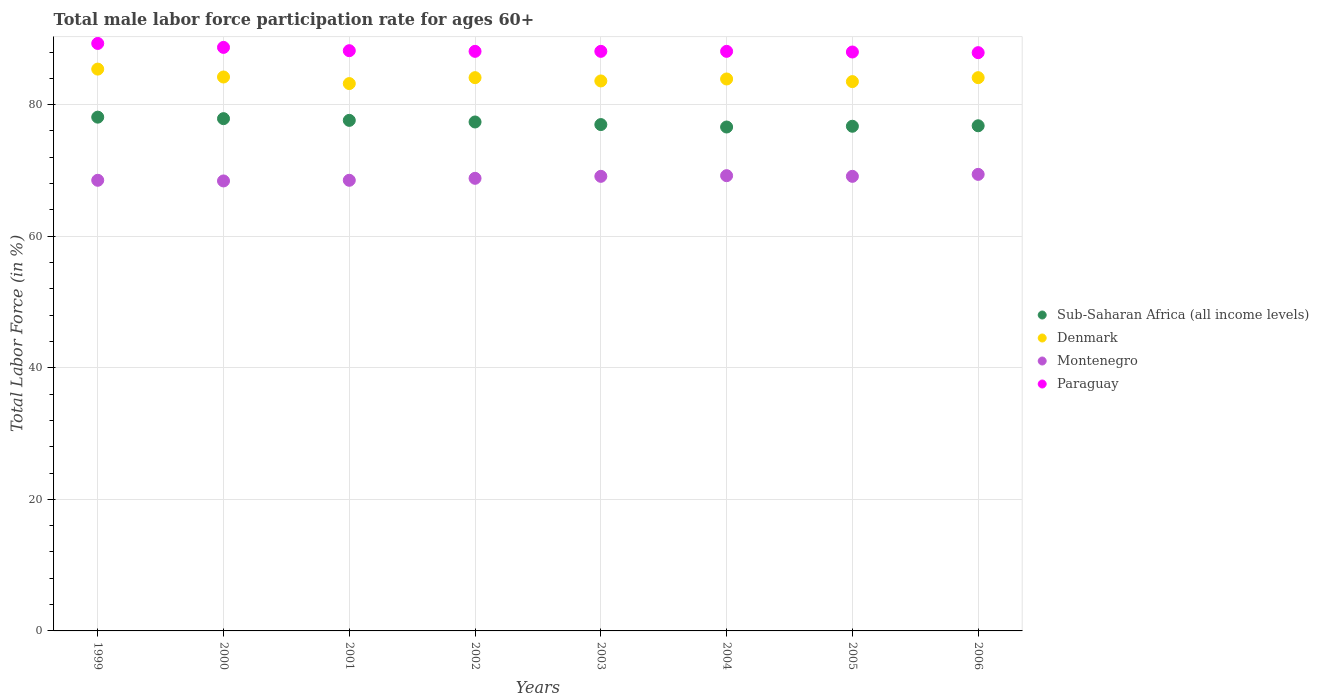What is the male labor force participation rate in Montenegro in 2002?
Your answer should be very brief. 68.8. Across all years, what is the maximum male labor force participation rate in Denmark?
Offer a very short reply. 85.4. Across all years, what is the minimum male labor force participation rate in Denmark?
Offer a very short reply. 83.2. In which year was the male labor force participation rate in Montenegro maximum?
Your answer should be very brief. 2006. What is the total male labor force participation rate in Sub-Saharan Africa (all income levels) in the graph?
Make the answer very short. 618. What is the difference between the male labor force participation rate in Denmark in 2000 and that in 2002?
Provide a succinct answer. 0.1. What is the difference between the male labor force participation rate in Paraguay in 2006 and the male labor force participation rate in Denmark in 2000?
Give a very brief answer. 3.7. What is the average male labor force participation rate in Denmark per year?
Your response must be concise. 84. In the year 1999, what is the difference between the male labor force participation rate in Montenegro and male labor force participation rate in Denmark?
Offer a very short reply. -16.9. What is the ratio of the male labor force participation rate in Sub-Saharan Africa (all income levels) in 2001 to that in 2004?
Your response must be concise. 1.01. Is the male labor force participation rate in Denmark in 1999 less than that in 2001?
Provide a succinct answer. No. What is the difference between the highest and the second highest male labor force participation rate in Sub-Saharan Africa (all income levels)?
Keep it short and to the point. 0.23. What is the difference between the highest and the lowest male labor force participation rate in Denmark?
Provide a succinct answer. 2.2. Is the male labor force participation rate in Denmark strictly greater than the male labor force participation rate in Sub-Saharan Africa (all income levels) over the years?
Offer a terse response. Yes. Is the male labor force participation rate in Paraguay strictly less than the male labor force participation rate in Denmark over the years?
Your answer should be very brief. No. How many dotlines are there?
Make the answer very short. 4. How many years are there in the graph?
Ensure brevity in your answer.  8. What is the difference between two consecutive major ticks on the Y-axis?
Provide a short and direct response. 20. Are the values on the major ticks of Y-axis written in scientific E-notation?
Your answer should be very brief. No. Does the graph contain any zero values?
Ensure brevity in your answer.  No. How many legend labels are there?
Your response must be concise. 4. What is the title of the graph?
Ensure brevity in your answer.  Total male labor force participation rate for ages 60+. Does "Heavily indebted poor countries" appear as one of the legend labels in the graph?
Keep it short and to the point. No. What is the label or title of the Y-axis?
Offer a very short reply. Total Labor Force (in %). What is the Total Labor Force (in %) of Sub-Saharan Africa (all income levels) in 1999?
Provide a succinct answer. 78.1. What is the Total Labor Force (in %) of Denmark in 1999?
Offer a terse response. 85.4. What is the Total Labor Force (in %) in Montenegro in 1999?
Make the answer very short. 68.5. What is the Total Labor Force (in %) of Paraguay in 1999?
Ensure brevity in your answer.  89.3. What is the Total Labor Force (in %) of Sub-Saharan Africa (all income levels) in 2000?
Give a very brief answer. 77.87. What is the Total Labor Force (in %) of Denmark in 2000?
Your answer should be compact. 84.2. What is the Total Labor Force (in %) of Montenegro in 2000?
Provide a short and direct response. 68.4. What is the Total Labor Force (in %) in Paraguay in 2000?
Provide a succinct answer. 88.7. What is the Total Labor Force (in %) of Sub-Saharan Africa (all income levels) in 2001?
Provide a succinct answer. 77.61. What is the Total Labor Force (in %) in Denmark in 2001?
Your response must be concise. 83.2. What is the Total Labor Force (in %) of Montenegro in 2001?
Provide a succinct answer. 68.5. What is the Total Labor Force (in %) of Paraguay in 2001?
Make the answer very short. 88.2. What is the Total Labor Force (in %) of Sub-Saharan Africa (all income levels) in 2002?
Offer a terse response. 77.36. What is the Total Labor Force (in %) of Denmark in 2002?
Your answer should be very brief. 84.1. What is the Total Labor Force (in %) of Montenegro in 2002?
Your answer should be very brief. 68.8. What is the Total Labor Force (in %) of Paraguay in 2002?
Your answer should be compact. 88.1. What is the Total Labor Force (in %) in Sub-Saharan Africa (all income levels) in 2003?
Your response must be concise. 76.97. What is the Total Labor Force (in %) of Denmark in 2003?
Make the answer very short. 83.6. What is the Total Labor Force (in %) of Montenegro in 2003?
Ensure brevity in your answer.  69.1. What is the Total Labor Force (in %) of Paraguay in 2003?
Your response must be concise. 88.1. What is the Total Labor Force (in %) in Sub-Saharan Africa (all income levels) in 2004?
Offer a terse response. 76.6. What is the Total Labor Force (in %) of Denmark in 2004?
Give a very brief answer. 83.9. What is the Total Labor Force (in %) of Montenegro in 2004?
Ensure brevity in your answer.  69.2. What is the Total Labor Force (in %) in Paraguay in 2004?
Provide a succinct answer. 88.1. What is the Total Labor Force (in %) in Sub-Saharan Africa (all income levels) in 2005?
Make the answer very short. 76.71. What is the Total Labor Force (in %) of Denmark in 2005?
Your answer should be compact. 83.5. What is the Total Labor Force (in %) of Montenegro in 2005?
Offer a very short reply. 69.1. What is the Total Labor Force (in %) of Paraguay in 2005?
Your answer should be compact. 88. What is the Total Labor Force (in %) in Sub-Saharan Africa (all income levels) in 2006?
Make the answer very short. 76.79. What is the Total Labor Force (in %) of Denmark in 2006?
Offer a very short reply. 84.1. What is the Total Labor Force (in %) in Montenegro in 2006?
Provide a short and direct response. 69.4. What is the Total Labor Force (in %) of Paraguay in 2006?
Give a very brief answer. 87.9. Across all years, what is the maximum Total Labor Force (in %) of Sub-Saharan Africa (all income levels)?
Keep it short and to the point. 78.1. Across all years, what is the maximum Total Labor Force (in %) of Denmark?
Provide a succinct answer. 85.4. Across all years, what is the maximum Total Labor Force (in %) in Montenegro?
Your answer should be compact. 69.4. Across all years, what is the maximum Total Labor Force (in %) of Paraguay?
Provide a succinct answer. 89.3. Across all years, what is the minimum Total Labor Force (in %) of Sub-Saharan Africa (all income levels)?
Offer a terse response. 76.6. Across all years, what is the minimum Total Labor Force (in %) in Denmark?
Make the answer very short. 83.2. Across all years, what is the minimum Total Labor Force (in %) in Montenegro?
Provide a succinct answer. 68.4. Across all years, what is the minimum Total Labor Force (in %) of Paraguay?
Provide a short and direct response. 87.9. What is the total Total Labor Force (in %) of Sub-Saharan Africa (all income levels) in the graph?
Your answer should be very brief. 618. What is the total Total Labor Force (in %) in Denmark in the graph?
Provide a short and direct response. 672. What is the total Total Labor Force (in %) of Montenegro in the graph?
Make the answer very short. 551. What is the total Total Labor Force (in %) of Paraguay in the graph?
Your answer should be very brief. 706.4. What is the difference between the Total Labor Force (in %) in Sub-Saharan Africa (all income levels) in 1999 and that in 2000?
Your response must be concise. 0.23. What is the difference between the Total Labor Force (in %) of Denmark in 1999 and that in 2000?
Your response must be concise. 1.2. What is the difference between the Total Labor Force (in %) in Montenegro in 1999 and that in 2000?
Ensure brevity in your answer.  0.1. What is the difference between the Total Labor Force (in %) of Sub-Saharan Africa (all income levels) in 1999 and that in 2001?
Your response must be concise. 0.49. What is the difference between the Total Labor Force (in %) of Paraguay in 1999 and that in 2001?
Your response must be concise. 1.1. What is the difference between the Total Labor Force (in %) in Sub-Saharan Africa (all income levels) in 1999 and that in 2002?
Offer a terse response. 0.73. What is the difference between the Total Labor Force (in %) of Paraguay in 1999 and that in 2002?
Keep it short and to the point. 1.2. What is the difference between the Total Labor Force (in %) in Sub-Saharan Africa (all income levels) in 1999 and that in 2003?
Ensure brevity in your answer.  1.13. What is the difference between the Total Labor Force (in %) in Denmark in 1999 and that in 2003?
Provide a succinct answer. 1.8. What is the difference between the Total Labor Force (in %) in Sub-Saharan Africa (all income levels) in 1999 and that in 2004?
Offer a terse response. 1.5. What is the difference between the Total Labor Force (in %) of Sub-Saharan Africa (all income levels) in 1999 and that in 2005?
Provide a succinct answer. 1.38. What is the difference between the Total Labor Force (in %) in Denmark in 1999 and that in 2005?
Your answer should be compact. 1.9. What is the difference between the Total Labor Force (in %) in Sub-Saharan Africa (all income levels) in 1999 and that in 2006?
Offer a terse response. 1.31. What is the difference between the Total Labor Force (in %) of Paraguay in 1999 and that in 2006?
Keep it short and to the point. 1.4. What is the difference between the Total Labor Force (in %) in Sub-Saharan Africa (all income levels) in 2000 and that in 2001?
Your answer should be very brief. 0.26. What is the difference between the Total Labor Force (in %) of Montenegro in 2000 and that in 2001?
Your response must be concise. -0.1. What is the difference between the Total Labor Force (in %) of Sub-Saharan Africa (all income levels) in 2000 and that in 2002?
Ensure brevity in your answer.  0.51. What is the difference between the Total Labor Force (in %) in Denmark in 2000 and that in 2002?
Offer a terse response. 0.1. What is the difference between the Total Labor Force (in %) of Montenegro in 2000 and that in 2002?
Provide a short and direct response. -0.4. What is the difference between the Total Labor Force (in %) in Paraguay in 2000 and that in 2002?
Your answer should be very brief. 0.6. What is the difference between the Total Labor Force (in %) of Sub-Saharan Africa (all income levels) in 2000 and that in 2003?
Give a very brief answer. 0.9. What is the difference between the Total Labor Force (in %) in Denmark in 2000 and that in 2003?
Give a very brief answer. 0.6. What is the difference between the Total Labor Force (in %) of Montenegro in 2000 and that in 2003?
Offer a very short reply. -0.7. What is the difference between the Total Labor Force (in %) in Sub-Saharan Africa (all income levels) in 2000 and that in 2004?
Provide a short and direct response. 1.27. What is the difference between the Total Labor Force (in %) in Sub-Saharan Africa (all income levels) in 2000 and that in 2005?
Offer a terse response. 1.16. What is the difference between the Total Labor Force (in %) of Denmark in 2000 and that in 2005?
Your response must be concise. 0.7. What is the difference between the Total Labor Force (in %) of Montenegro in 2000 and that in 2005?
Provide a succinct answer. -0.7. What is the difference between the Total Labor Force (in %) of Sub-Saharan Africa (all income levels) in 2000 and that in 2006?
Your answer should be compact. 1.08. What is the difference between the Total Labor Force (in %) in Denmark in 2000 and that in 2006?
Ensure brevity in your answer.  0.1. What is the difference between the Total Labor Force (in %) in Montenegro in 2000 and that in 2006?
Provide a short and direct response. -1. What is the difference between the Total Labor Force (in %) in Sub-Saharan Africa (all income levels) in 2001 and that in 2002?
Your response must be concise. 0.24. What is the difference between the Total Labor Force (in %) of Sub-Saharan Africa (all income levels) in 2001 and that in 2003?
Your answer should be compact. 0.64. What is the difference between the Total Labor Force (in %) in Denmark in 2001 and that in 2003?
Offer a very short reply. -0.4. What is the difference between the Total Labor Force (in %) of Sub-Saharan Africa (all income levels) in 2001 and that in 2004?
Offer a very short reply. 1.01. What is the difference between the Total Labor Force (in %) of Montenegro in 2001 and that in 2004?
Your response must be concise. -0.7. What is the difference between the Total Labor Force (in %) in Paraguay in 2001 and that in 2004?
Ensure brevity in your answer.  0.1. What is the difference between the Total Labor Force (in %) in Sub-Saharan Africa (all income levels) in 2001 and that in 2005?
Offer a terse response. 0.89. What is the difference between the Total Labor Force (in %) of Denmark in 2001 and that in 2005?
Your answer should be compact. -0.3. What is the difference between the Total Labor Force (in %) in Sub-Saharan Africa (all income levels) in 2001 and that in 2006?
Give a very brief answer. 0.82. What is the difference between the Total Labor Force (in %) in Montenegro in 2001 and that in 2006?
Offer a terse response. -0.9. What is the difference between the Total Labor Force (in %) in Paraguay in 2001 and that in 2006?
Your answer should be very brief. 0.3. What is the difference between the Total Labor Force (in %) of Sub-Saharan Africa (all income levels) in 2002 and that in 2003?
Offer a terse response. 0.4. What is the difference between the Total Labor Force (in %) in Sub-Saharan Africa (all income levels) in 2002 and that in 2004?
Give a very brief answer. 0.77. What is the difference between the Total Labor Force (in %) in Denmark in 2002 and that in 2004?
Keep it short and to the point. 0.2. What is the difference between the Total Labor Force (in %) in Paraguay in 2002 and that in 2004?
Offer a terse response. 0. What is the difference between the Total Labor Force (in %) in Sub-Saharan Africa (all income levels) in 2002 and that in 2005?
Ensure brevity in your answer.  0.65. What is the difference between the Total Labor Force (in %) of Montenegro in 2002 and that in 2005?
Provide a succinct answer. -0.3. What is the difference between the Total Labor Force (in %) of Sub-Saharan Africa (all income levels) in 2002 and that in 2006?
Ensure brevity in your answer.  0.58. What is the difference between the Total Labor Force (in %) in Denmark in 2002 and that in 2006?
Your answer should be compact. 0. What is the difference between the Total Labor Force (in %) of Sub-Saharan Africa (all income levels) in 2003 and that in 2004?
Your answer should be very brief. 0.37. What is the difference between the Total Labor Force (in %) in Denmark in 2003 and that in 2004?
Your response must be concise. -0.3. What is the difference between the Total Labor Force (in %) in Montenegro in 2003 and that in 2004?
Your response must be concise. -0.1. What is the difference between the Total Labor Force (in %) in Sub-Saharan Africa (all income levels) in 2003 and that in 2005?
Provide a succinct answer. 0.26. What is the difference between the Total Labor Force (in %) of Paraguay in 2003 and that in 2005?
Your answer should be very brief. 0.1. What is the difference between the Total Labor Force (in %) in Sub-Saharan Africa (all income levels) in 2003 and that in 2006?
Offer a terse response. 0.18. What is the difference between the Total Labor Force (in %) of Denmark in 2003 and that in 2006?
Keep it short and to the point. -0.5. What is the difference between the Total Labor Force (in %) in Montenegro in 2003 and that in 2006?
Give a very brief answer. -0.3. What is the difference between the Total Labor Force (in %) in Sub-Saharan Africa (all income levels) in 2004 and that in 2005?
Give a very brief answer. -0.12. What is the difference between the Total Labor Force (in %) in Montenegro in 2004 and that in 2005?
Your answer should be compact. 0.1. What is the difference between the Total Labor Force (in %) of Paraguay in 2004 and that in 2005?
Your response must be concise. 0.1. What is the difference between the Total Labor Force (in %) of Sub-Saharan Africa (all income levels) in 2004 and that in 2006?
Make the answer very short. -0.19. What is the difference between the Total Labor Force (in %) of Paraguay in 2004 and that in 2006?
Your answer should be very brief. 0.2. What is the difference between the Total Labor Force (in %) in Sub-Saharan Africa (all income levels) in 2005 and that in 2006?
Provide a succinct answer. -0.07. What is the difference between the Total Labor Force (in %) in Denmark in 2005 and that in 2006?
Offer a very short reply. -0.6. What is the difference between the Total Labor Force (in %) in Paraguay in 2005 and that in 2006?
Offer a terse response. 0.1. What is the difference between the Total Labor Force (in %) of Sub-Saharan Africa (all income levels) in 1999 and the Total Labor Force (in %) of Denmark in 2000?
Provide a succinct answer. -6.1. What is the difference between the Total Labor Force (in %) of Sub-Saharan Africa (all income levels) in 1999 and the Total Labor Force (in %) of Montenegro in 2000?
Give a very brief answer. 9.7. What is the difference between the Total Labor Force (in %) in Sub-Saharan Africa (all income levels) in 1999 and the Total Labor Force (in %) in Paraguay in 2000?
Give a very brief answer. -10.6. What is the difference between the Total Labor Force (in %) in Denmark in 1999 and the Total Labor Force (in %) in Montenegro in 2000?
Offer a very short reply. 17. What is the difference between the Total Labor Force (in %) in Montenegro in 1999 and the Total Labor Force (in %) in Paraguay in 2000?
Your answer should be very brief. -20.2. What is the difference between the Total Labor Force (in %) in Sub-Saharan Africa (all income levels) in 1999 and the Total Labor Force (in %) in Denmark in 2001?
Offer a terse response. -5.1. What is the difference between the Total Labor Force (in %) in Sub-Saharan Africa (all income levels) in 1999 and the Total Labor Force (in %) in Montenegro in 2001?
Offer a terse response. 9.6. What is the difference between the Total Labor Force (in %) of Sub-Saharan Africa (all income levels) in 1999 and the Total Labor Force (in %) of Paraguay in 2001?
Provide a short and direct response. -10.1. What is the difference between the Total Labor Force (in %) in Montenegro in 1999 and the Total Labor Force (in %) in Paraguay in 2001?
Provide a short and direct response. -19.7. What is the difference between the Total Labor Force (in %) of Sub-Saharan Africa (all income levels) in 1999 and the Total Labor Force (in %) of Denmark in 2002?
Your answer should be very brief. -6. What is the difference between the Total Labor Force (in %) in Sub-Saharan Africa (all income levels) in 1999 and the Total Labor Force (in %) in Montenegro in 2002?
Your answer should be compact. 9.3. What is the difference between the Total Labor Force (in %) of Sub-Saharan Africa (all income levels) in 1999 and the Total Labor Force (in %) of Paraguay in 2002?
Your answer should be compact. -10. What is the difference between the Total Labor Force (in %) in Denmark in 1999 and the Total Labor Force (in %) in Montenegro in 2002?
Provide a succinct answer. 16.6. What is the difference between the Total Labor Force (in %) of Denmark in 1999 and the Total Labor Force (in %) of Paraguay in 2002?
Provide a short and direct response. -2.7. What is the difference between the Total Labor Force (in %) in Montenegro in 1999 and the Total Labor Force (in %) in Paraguay in 2002?
Ensure brevity in your answer.  -19.6. What is the difference between the Total Labor Force (in %) of Sub-Saharan Africa (all income levels) in 1999 and the Total Labor Force (in %) of Denmark in 2003?
Provide a succinct answer. -5.5. What is the difference between the Total Labor Force (in %) of Sub-Saharan Africa (all income levels) in 1999 and the Total Labor Force (in %) of Montenegro in 2003?
Make the answer very short. 9. What is the difference between the Total Labor Force (in %) in Sub-Saharan Africa (all income levels) in 1999 and the Total Labor Force (in %) in Paraguay in 2003?
Your response must be concise. -10. What is the difference between the Total Labor Force (in %) in Denmark in 1999 and the Total Labor Force (in %) in Paraguay in 2003?
Give a very brief answer. -2.7. What is the difference between the Total Labor Force (in %) in Montenegro in 1999 and the Total Labor Force (in %) in Paraguay in 2003?
Keep it short and to the point. -19.6. What is the difference between the Total Labor Force (in %) of Sub-Saharan Africa (all income levels) in 1999 and the Total Labor Force (in %) of Denmark in 2004?
Provide a succinct answer. -5.8. What is the difference between the Total Labor Force (in %) of Sub-Saharan Africa (all income levels) in 1999 and the Total Labor Force (in %) of Montenegro in 2004?
Offer a very short reply. 8.9. What is the difference between the Total Labor Force (in %) in Sub-Saharan Africa (all income levels) in 1999 and the Total Labor Force (in %) in Paraguay in 2004?
Your response must be concise. -10. What is the difference between the Total Labor Force (in %) in Denmark in 1999 and the Total Labor Force (in %) in Montenegro in 2004?
Offer a terse response. 16.2. What is the difference between the Total Labor Force (in %) in Montenegro in 1999 and the Total Labor Force (in %) in Paraguay in 2004?
Keep it short and to the point. -19.6. What is the difference between the Total Labor Force (in %) in Sub-Saharan Africa (all income levels) in 1999 and the Total Labor Force (in %) in Denmark in 2005?
Give a very brief answer. -5.4. What is the difference between the Total Labor Force (in %) in Sub-Saharan Africa (all income levels) in 1999 and the Total Labor Force (in %) in Montenegro in 2005?
Offer a terse response. 9. What is the difference between the Total Labor Force (in %) in Sub-Saharan Africa (all income levels) in 1999 and the Total Labor Force (in %) in Paraguay in 2005?
Your answer should be compact. -9.9. What is the difference between the Total Labor Force (in %) in Denmark in 1999 and the Total Labor Force (in %) in Montenegro in 2005?
Offer a terse response. 16.3. What is the difference between the Total Labor Force (in %) in Denmark in 1999 and the Total Labor Force (in %) in Paraguay in 2005?
Your answer should be very brief. -2.6. What is the difference between the Total Labor Force (in %) in Montenegro in 1999 and the Total Labor Force (in %) in Paraguay in 2005?
Provide a short and direct response. -19.5. What is the difference between the Total Labor Force (in %) of Sub-Saharan Africa (all income levels) in 1999 and the Total Labor Force (in %) of Denmark in 2006?
Offer a terse response. -6. What is the difference between the Total Labor Force (in %) in Sub-Saharan Africa (all income levels) in 1999 and the Total Labor Force (in %) in Montenegro in 2006?
Make the answer very short. 8.7. What is the difference between the Total Labor Force (in %) of Sub-Saharan Africa (all income levels) in 1999 and the Total Labor Force (in %) of Paraguay in 2006?
Offer a terse response. -9.8. What is the difference between the Total Labor Force (in %) in Denmark in 1999 and the Total Labor Force (in %) in Paraguay in 2006?
Provide a succinct answer. -2.5. What is the difference between the Total Labor Force (in %) in Montenegro in 1999 and the Total Labor Force (in %) in Paraguay in 2006?
Keep it short and to the point. -19.4. What is the difference between the Total Labor Force (in %) in Sub-Saharan Africa (all income levels) in 2000 and the Total Labor Force (in %) in Denmark in 2001?
Your answer should be very brief. -5.33. What is the difference between the Total Labor Force (in %) of Sub-Saharan Africa (all income levels) in 2000 and the Total Labor Force (in %) of Montenegro in 2001?
Ensure brevity in your answer.  9.37. What is the difference between the Total Labor Force (in %) in Sub-Saharan Africa (all income levels) in 2000 and the Total Labor Force (in %) in Paraguay in 2001?
Your answer should be compact. -10.33. What is the difference between the Total Labor Force (in %) in Denmark in 2000 and the Total Labor Force (in %) in Paraguay in 2001?
Give a very brief answer. -4. What is the difference between the Total Labor Force (in %) of Montenegro in 2000 and the Total Labor Force (in %) of Paraguay in 2001?
Ensure brevity in your answer.  -19.8. What is the difference between the Total Labor Force (in %) in Sub-Saharan Africa (all income levels) in 2000 and the Total Labor Force (in %) in Denmark in 2002?
Make the answer very short. -6.23. What is the difference between the Total Labor Force (in %) in Sub-Saharan Africa (all income levels) in 2000 and the Total Labor Force (in %) in Montenegro in 2002?
Offer a terse response. 9.07. What is the difference between the Total Labor Force (in %) of Sub-Saharan Africa (all income levels) in 2000 and the Total Labor Force (in %) of Paraguay in 2002?
Make the answer very short. -10.23. What is the difference between the Total Labor Force (in %) in Denmark in 2000 and the Total Labor Force (in %) in Montenegro in 2002?
Your answer should be very brief. 15.4. What is the difference between the Total Labor Force (in %) in Denmark in 2000 and the Total Labor Force (in %) in Paraguay in 2002?
Your answer should be very brief. -3.9. What is the difference between the Total Labor Force (in %) in Montenegro in 2000 and the Total Labor Force (in %) in Paraguay in 2002?
Provide a succinct answer. -19.7. What is the difference between the Total Labor Force (in %) of Sub-Saharan Africa (all income levels) in 2000 and the Total Labor Force (in %) of Denmark in 2003?
Ensure brevity in your answer.  -5.73. What is the difference between the Total Labor Force (in %) of Sub-Saharan Africa (all income levels) in 2000 and the Total Labor Force (in %) of Montenegro in 2003?
Provide a short and direct response. 8.77. What is the difference between the Total Labor Force (in %) in Sub-Saharan Africa (all income levels) in 2000 and the Total Labor Force (in %) in Paraguay in 2003?
Provide a short and direct response. -10.23. What is the difference between the Total Labor Force (in %) of Denmark in 2000 and the Total Labor Force (in %) of Montenegro in 2003?
Offer a very short reply. 15.1. What is the difference between the Total Labor Force (in %) of Montenegro in 2000 and the Total Labor Force (in %) of Paraguay in 2003?
Your response must be concise. -19.7. What is the difference between the Total Labor Force (in %) in Sub-Saharan Africa (all income levels) in 2000 and the Total Labor Force (in %) in Denmark in 2004?
Make the answer very short. -6.03. What is the difference between the Total Labor Force (in %) in Sub-Saharan Africa (all income levels) in 2000 and the Total Labor Force (in %) in Montenegro in 2004?
Keep it short and to the point. 8.67. What is the difference between the Total Labor Force (in %) of Sub-Saharan Africa (all income levels) in 2000 and the Total Labor Force (in %) of Paraguay in 2004?
Keep it short and to the point. -10.23. What is the difference between the Total Labor Force (in %) in Denmark in 2000 and the Total Labor Force (in %) in Montenegro in 2004?
Offer a very short reply. 15. What is the difference between the Total Labor Force (in %) of Montenegro in 2000 and the Total Labor Force (in %) of Paraguay in 2004?
Your response must be concise. -19.7. What is the difference between the Total Labor Force (in %) of Sub-Saharan Africa (all income levels) in 2000 and the Total Labor Force (in %) of Denmark in 2005?
Your response must be concise. -5.63. What is the difference between the Total Labor Force (in %) in Sub-Saharan Africa (all income levels) in 2000 and the Total Labor Force (in %) in Montenegro in 2005?
Ensure brevity in your answer.  8.77. What is the difference between the Total Labor Force (in %) in Sub-Saharan Africa (all income levels) in 2000 and the Total Labor Force (in %) in Paraguay in 2005?
Ensure brevity in your answer.  -10.13. What is the difference between the Total Labor Force (in %) in Denmark in 2000 and the Total Labor Force (in %) in Paraguay in 2005?
Your answer should be compact. -3.8. What is the difference between the Total Labor Force (in %) in Montenegro in 2000 and the Total Labor Force (in %) in Paraguay in 2005?
Provide a succinct answer. -19.6. What is the difference between the Total Labor Force (in %) in Sub-Saharan Africa (all income levels) in 2000 and the Total Labor Force (in %) in Denmark in 2006?
Keep it short and to the point. -6.23. What is the difference between the Total Labor Force (in %) in Sub-Saharan Africa (all income levels) in 2000 and the Total Labor Force (in %) in Montenegro in 2006?
Your response must be concise. 8.47. What is the difference between the Total Labor Force (in %) in Sub-Saharan Africa (all income levels) in 2000 and the Total Labor Force (in %) in Paraguay in 2006?
Give a very brief answer. -10.03. What is the difference between the Total Labor Force (in %) of Montenegro in 2000 and the Total Labor Force (in %) of Paraguay in 2006?
Ensure brevity in your answer.  -19.5. What is the difference between the Total Labor Force (in %) in Sub-Saharan Africa (all income levels) in 2001 and the Total Labor Force (in %) in Denmark in 2002?
Ensure brevity in your answer.  -6.49. What is the difference between the Total Labor Force (in %) in Sub-Saharan Africa (all income levels) in 2001 and the Total Labor Force (in %) in Montenegro in 2002?
Your response must be concise. 8.81. What is the difference between the Total Labor Force (in %) of Sub-Saharan Africa (all income levels) in 2001 and the Total Labor Force (in %) of Paraguay in 2002?
Your answer should be very brief. -10.49. What is the difference between the Total Labor Force (in %) in Denmark in 2001 and the Total Labor Force (in %) in Montenegro in 2002?
Your answer should be compact. 14.4. What is the difference between the Total Labor Force (in %) in Montenegro in 2001 and the Total Labor Force (in %) in Paraguay in 2002?
Provide a short and direct response. -19.6. What is the difference between the Total Labor Force (in %) of Sub-Saharan Africa (all income levels) in 2001 and the Total Labor Force (in %) of Denmark in 2003?
Your answer should be compact. -5.99. What is the difference between the Total Labor Force (in %) of Sub-Saharan Africa (all income levels) in 2001 and the Total Labor Force (in %) of Montenegro in 2003?
Provide a succinct answer. 8.51. What is the difference between the Total Labor Force (in %) of Sub-Saharan Africa (all income levels) in 2001 and the Total Labor Force (in %) of Paraguay in 2003?
Give a very brief answer. -10.49. What is the difference between the Total Labor Force (in %) in Montenegro in 2001 and the Total Labor Force (in %) in Paraguay in 2003?
Provide a succinct answer. -19.6. What is the difference between the Total Labor Force (in %) of Sub-Saharan Africa (all income levels) in 2001 and the Total Labor Force (in %) of Denmark in 2004?
Provide a short and direct response. -6.29. What is the difference between the Total Labor Force (in %) in Sub-Saharan Africa (all income levels) in 2001 and the Total Labor Force (in %) in Montenegro in 2004?
Provide a short and direct response. 8.41. What is the difference between the Total Labor Force (in %) of Sub-Saharan Africa (all income levels) in 2001 and the Total Labor Force (in %) of Paraguay in 2004?
Your answer should be compact. -10.49. What is the difference between the Total Labor Force (in %) of Denmark in 2001 and the Total Labor Force (in %) of Montenegro in 2004?
Give a very brief answer. 14. What is the difference between the Total Labor Force (in %) in Montenegro in 2001 and the Total Labor Force (in %) in Paraguay in 2004?
Provide a succinct answer. -19.6. What is the difference between the Total Labor Force (in %) of Sub-Saharan Africa (all income levels) in 2001 and the Total Labor Force (in %) of Denmark in 2005?
Offer a terse response. -5.89. What is the difference between the Total Labor Force (in %) in Sub-Saharan Africa (all income levels) in 2001 and the Total Labor Force (in %) in Montenegro in 2005?
Your answer should be very brief. 8.51. What is the difference between the Total Labor Force (in %) of Sub-Saharan Africa (all income levels) in 2001 and the Total Labor Force (in %) of Paraguay in 2005?
Provide a succinct answer. -10.39. What is the difference between the Total Labor Force (in %) in Denmark in 2001 and the Total Labor Force (in %) in Montenegro in 2005?
Ensure brevity in your answer.  14.1. What is the difference between the Total Labor Force (in %) of Denmark in 2001 and the Total Labor Force (in %) of Paraguay in 2005?
Make the answer very short. -4.8. What is the difference between the Total Labor Force (in %) of Montenegro in 2001 and the Total Labor Force (in %) of Paraguay in 2005?
Keep it short and to the point. -19.5. What is the difference between the Total Labor Force (in %) in Sub-Saharan Africa (all income levels) in 2001 and the Total Labor Force (in %) in Denmark in 2006?
Your response must be concise. -6.49. What is the difference between the Total Labor Force (in %) in Sub-Saharan Africa (all income levels) in 2001 and the Total Labor Force (in %) in Montenegro in 2006?
Ensure brevity in your answer.  8.21. What is the difference between the Total Labor Force (in %) in Sub-Saharan Africa (all income levels) in 2001 and the Total Labor Force (in %) in Paraguay in 2006?
Your answer should be very brief. -10.29. What is the difference between the Total Labor Force (in %) in Denmark in 2001 and the Total Labor Force (in %) in Montenegro in 2006?
Your answer should be compact. 13.8. What is the difference between the Total Labor Force (in %) in Denmark in 2001 and the Total Labor Force (in %) in Paraguay in 2006?
Provide a succinct answer. -4.7. What is the difference between the Total Labor Force (in %) of Montenegro in 2001 and the Total Labor Force (in %) of Paraguay in 2006?
Your answer should be compact. -19.4. What is the difference between the Total Labor Force (in %) of Sub-Saharan Africa (all income levels) in 2002 and the Total Labor Force (in %) of Denmark in 2003?
Provide a succinct answer. -6.24. What is the difference between the Total Labor Force (in %) in Sub-Saharan Africa (all income levels) in 2002 and the Total Labor Force (in %) in Montenegro in 2003?
Offer a terse response. 8.26. What is the difference between the Total Labor Force (in %) in Sub-Saharan Africa (all income levels) in 2002 and the Total Labor Force (in %) in Paraguay in 2003?
Keep it short and to the point. -10.74. What is the difference between the Total Labor Force (in %) in Montenegro in 2002 and the Total Labor Force (in %) in Paraguay in 2003?
Your answer should be very brief. -19.3. What is the difference between the Total Labor Force (in %) in Sub-Saharan Africa (all income levels) in 2002 and the Total Labor Force (in %) in Denmark in 2004?
Your response must be concise. -6.54. What is the difference between the Total Labor Force (in %) of Sub-Saharan Africa (all income levels) in 2002 and the Total Labor Force (in %) of Montenegro in 2004?
Provide a short and direct response. 8.16. What is the difference between the Total Labor Force (in %) of Sub-Saharan Africa (all income levels) in 2002 and the Total Labor Force (in %) of Paraguay in 2004?
Make the answer very short. -10.74. What is the difference between the Total Labor Force (in %) in Montenegro in 2002 and the Total Labor Force (in %) in Paraguay in 2004?
Your response must be concise. -19.3. What is the difference between the Total Labor Force (in %) in Sub-Saharan Africa (all income levels) in 2002 and the Total Labor Force (in %) in Denmark in 2005?
Give a very brief answer. -6.14. What is the difference between the Total Labor Force (in %) of Sub-Saharan Africa (all income levels) in 2002 and the Total Labor Force (in %) of Montenegro in 2005?
Make the answer very short. 8.26. What is the difference between the Total Labor Force (in %) in Sub-Saharan Africa (all income levels) in 2002 and the Total Labor Force (in %) in Paraguay in 2005?
Ensure brevity in your answer.  -10.64. What is the difference between the Total Labor Force (in %) of Montenegro in 2002 and the Total Labor Force (in %) of Paraguay in 2005?
Your response must be concise. -19.2. What is the difference between the Total Labor Force (in %) of Sub-Saharan Africa (all income levels) in 2002 and the Total Labor Force (in %) of Denmark in 2006?
Provide a succinct answer. -6.74. What is the difference between the Total Labor Force (in %) of Sub-Saharan Africa (all income levels) in 2002 and the Total Labor Force (in %) of Montenegro in 2006?
Provide a succinct answer. 7.96. What is the difference between the Total Labor Force (in %) of Sub-Saharan Africa (all income levels) in 2002 and the Total Labor Force (in %) of Paraguay in 2006?
Make the answer very short. -10.54. What is the difference between the Total Labor Force (in %) of Denmark in 2002 and the Total Labor Force (in %) of Paraguay in 2006?
Your answer should be very brief. -3.8. What is the difference between the Total Labor Force (in %) in Montenegro in 2002 and the Total Labor Force (in %) in Paraguay in 2006?
Keep it short and to the point. -19.1. What is the difference between the Total Labor Force (in %) in Sub-Saharan Africa (all income levels) in 2003 and the Total Labor Force (in %) in Denmark in 2004?
Provide a short and direct response. -6.93. What is the difference between the Total Labor Force (in %) of Sub-Saharan Africa (all income levels) in 2003 and the Total Labor Force (in %) of Montenegro in 2004?
Offer a very short reply. 7.77. What is the difference between the Total Labor Force (in %) of Sub-Saharan Africa (all income levels) in 2003 and the Total Labor Force (in %) of Paraguay in 2004?
Your response must be concise. -11.13. What is the difference between the Total Labor Force (in %) of Denmark in 2003 and the Total Labor Force (in %) of Paraguay in 2004?
Provide a succinct answer. -4.5. What is the difference between the Total Labor Force (in %) in Sub-Saharan Africa (all income levels) in 2003 and the Total Labor Force (in %) in Denmark in 2005?
Provide a short and direct response. -6.53. What is the difference between the Total Labor Force (in %) in Sub-Saharan Africa (all income levels) in 2003 and the Total Labor Force (in %) in Montenegro in 2005?
Keep it short and to the point. 7.87. What is the difference between the Total Labor Force (in %) in Sub-Saharan Africa (all income levels) in 2003 and the Total Labor Force (in %) in Paraguay in 2005?
Make the answer very short. -11.03. What is the difference between the Total Labor Force (in %) in Denmark in 2003 and the Total Labor Force (in %) in Montenegro in 2005?
Offer a very short reply. 14.5. What is the difference between the Total Labor Force (in %) of Montenegro in 2003 and the Total Labor Force (in %) of Paraguay in 2005?
Give a very brief answer. -18.9. What is the difference between the Total Labor Force (in %) in Sub-Saharan Africa (all income levels) in 2003 and the Total Labor Force (in %) in Denmark in 2006?
Offer a very short reply. -7.13. What is the difference between the Total Labor Force (in %) in Sub-Saharan Africa (all income levels) in 2003 and the Total Labor Force (in %) in Montenegro in 2006?
Offer a terse response. 7.57. What is the difference between the Total Labor Force (in %) of Sub-Saharan Africa (all income levels) in 2003 and the Total Labor Force (in %) of Paraguay in 2006?
Offer a very short reply. -10.93. What is the difference between the Total Labor Force (in %) of Montenegro in 2003 and the Total Labor Force (in %) of Paraguay in 2006?
Offer a terse response. -18.8. What is the difference between the Total Labor Force (in %) in Sub-Saharan Africa (all income levels) in 2004 and the Total Labor Force (in %) in Denmark in 2005?
Offer a terse response. -6.9. What is the difference between the Total Labor Force (in %) in Sub-Saharan Africa (all income levels) in 2004 and the Total Labor Force (in %) in Montenegro in 2005?
Your answer should be compact. 7.5. What is the difference between the Total Labor Force (in %) of Sub-Saharan Africa (all income levels) in 2004 and the Total Labor Force (in %) of Paraguay in 2005?
Make the answer very short. -11.4. What is the difference between the Total Labor Force (in %) of Denmark in 2004 and the Total Labor Force (in %) of Paraguay in 2005?
Keep it short and to the point. -4.1. What is the difference between the Total Labor Force (in %) of Montenegro in 2004 and the Total Labor Force (in %) of Paraguay in 2005?
Your answer should be very brief. -18.8. What is the difference between the Total Labor Force (in %) of Sub-Saharan Africa (all income levels) in 2004 and the Total Labor Force (in %) of Denmark in 2006?
Your answer should be compact. -7.5. What is the difference between the Total Labor Force (in %) in Sub-Saharan Africa (all income levels) in 2004 and the Total Labor Force (in %) in Montenegro in 2006?
Make the answer very short. 7.2. What is the difference between the Total Labor Force (in %) of Sub-Saharan Africa (all income levels) in 2004 and the Total Labor Force (in %) of Paraguay in 2006?
Your response must be concise. -11.3. What is the difference between the Total Labor Force (in %) in Montenegro in 2004 and the Total Labor Force (in %) in Paraguay in 2006?
Your answer should be very brief. -18.7. What is the difference between the Total Labor Force (in %) of Sub-Saharan Africa (all income levels) in 2005 and the Total Labor Force (in %) of Denmark in 2006?
Keep it short and to the point. -7.39. What is the difference between the Total Labor Force (in %) of Sub-Saharan Africa (all income levels) in 2005 and the Total Labor Force (in %) of Montenegro in 2006?
Ensure brevity in your answer.  7.31. What is the difference between the Total Labor Force (in %) in Sub-Saharan Africa (all income levels) in 2005 and the Total Labor Force (in %) in Paraguay in 2006?
Your answer should be very brief. -11.19. What is the difference between the Total Labor Force (in %) in Denmark in 2005 and the Total Labor Force (in %) in Montenegro in 2006?
Your response must be concise. 14.1. What is the difference between the Total Labor Force (in %) in Denmark in 2005 and the Total Labor Force (in %) in Paraguay in 2006?
Your response must be concise. -4.4. What is the difference between the Total Labor Force (in %) of Montenegro in 2005 and the Total Labor Force (in %) of Paraguay in 2006?
Offer a terse response. -18.8. What is the average Total Labor Force (in %) of Sub-Saharan Africa (all income levels) per year?
Offer a terse response. 77.25. What is the average Total Labor Force (in %) of Montenegro per year?
Provide a short and direct response. 68.88. What is the average Total Labor Force (in %) in Paraguay per year?
Provide a short and direct response. 88.3. In the year 1999, what is the difference between the Total Labor Force (in %) of Sub-Saharan Africa (all income levels) and Total Labor Force (in %) of Denmark?
Give a very brief answer. -7.3. In the year 1999, what is the difference between the Total Labor Force (in %) of Sub-Saharan Africa (all income levels) and Total Labor Force (in %) of Montenegro?
Provide a short and direct response. 9.6. In the year 1999, what is the difference between the Total Labor Force (in %) of Sub-Saharan Africa (all income levels) and Total Labor Force (in %) of Paraguay?
Offer a terse response. -11.2. In the year 1999, what is the difference between the Total Labor Force (in %) of Denmark and Total Labor Force (in %) of Montenegro?
Offer a terse response. 16.9. In the year 1999, what is the difference between the Total Labor Force (in %) in Denmark and Total Labor Force (in %) in Paraguay?
Provide a succinct answer. -3.9. In the year 1999, what is the difference between the Total Labor Force (in %) in Montenegro and Total Labor Force (in %) in Paraguay?
Make the answer very short. -20.8. In the year 2000, what is the difference between the Total Labor Force (in %) of Sub-Saharan Africa (all income levels) and Total Labor Force (in %) of Denmark?
Offer a terse response. -6.33. In the year 2000, what is the difference between the Total Labor Force (in %) of Sub-Saharan Africa (all income levels) and Total Labor Force (in %) of Montenegro?
Make the answer very short. 9.47. In the year 2000, what is the difference between the Total Labor Force (in %) in Sub-Saharan Africa (all income levels) and Total Labor Force (in %) in Paraguay?
Offer a terse response. -10.83. In the year 2000, what is the difference between the Total Labor Force (in %) of Denmark and Total Labor Force (in %) of Paraguay?
Ensure brevity in your answer.  -4.5. In the year 2000, what is the difference between the Total Labor Force (in %) of Montenegro and Total Labor Force (in %) of Paraguay?
Your answer should be very brief. -20.3. In the year 2001, what is the difference between the Total Labor Force (in %) of Sub-Saharan Africa (all income levels) and Total Labor Force (in %) of Denmark?
Your answer should be very brief. -5.59. In the year 2001, what is the difference between the Total Labor Force (in %) in Sub-Saharan Africa (all income levels) and Total Labor Force (in %) in Montenegro?
Make the answer very short. 9.11. In the year 2001, what is the difference between the Total Labor Force (in %) in Sub-Saharan Africa (all income levels) and Total Labor Force (in %) in Paraguay?
Provide a succinct answer. -10.59. In the year 2001, what is the difference between the Total Labor Force (in %) of Montenegro and Total Labor Force (in %) of Paraguay?
Provide a succinct answer. -19.7. In the year 2002, what is the difference between the Total Labor Force (in %) of Sub-Saharan Africa (all income levels) and Total Labor Force (in %) of Denmark?
Offer a terse response. -6.74. In the year 2002, what is the difference between the Total Labor Force (in %) of Sub-Saharan Africa (all income levels) and Total Labor Force (in %) of Montenegro?
Your response must be concise. 8.56. In the year 2002, what is the difference between the Total Labor Force (in %) in Sub-Saharan Africa (all income levels) and Total Labor Force (in %) in Paraguay?
Provide a succinct answer. -10.74. In the year 2002, what is the difference between the Total Labor Force (in %) in Denmark and Total Labor Force (in %) in Montenegro?
Your answer should be very brief. 15.3. In the year 2002, what is the difference between the Total Labor Force (in %) in Montenegro and Total Labor Force (in %) in Paraguay?
Your response must be concise. -19.3. In the year 2003, what is the difference between the Total Labor Force (in %) of Sub-Saharan Africa (all income levels) and Total Labor Force (in %) of Denmark?
Ensure brevity in your answer.  -6.63. In the year 2003, what is the difference between the Total Labor Force (in %) of Sub-Saharan Africa (all income levels) and Total Labor Force (in %) of Montenegro?
Your response must be concise. 7.87. In the year 2003, what is the difference between the Total Labor Force (in %) in Sub-Saharan Africa (all income levels) and Total Labor Force (in %) in Paraguay?
Make the answer very short. -11.13. In the year 2004, what is the difference between the Total Labor Force (in %) in Sub-Saharan Africa (all income levels) and Total Labor Force (in %) in Denmark?
Offer a very short reply. -7.3. In the year 2004, what is the difference between the Total Labor Force (in %) of Sub-Saharan Africa (all income levels) and Total Labor Force (in %) of Montenegro?
Offer a very short reply. 7.4. In the year 2004, what is the difference between the Total Labor Force (in %) of Sub-Saharan Africa (all income levels) and Total Labor Force (in %) of Paraguay?
Offer a very short reply. -11.5. In the year 2004, what is the difference between the Total Labor Force (in %) of Denmark and Total Labor Force (in %) of Montenegro?
Your answer should be compact. 14.7. In the year 2004, what is the difference between the Total Labor Force (in %) in Denmark and Total Labor Force (in %) in Paraguay?
Keep it short and to the point. -4.2. In the year 2004, what is the difference between the Total Labor Force (in %) in Montenegro and Total Labor Force (in %) in Paraguay?
Give a very brief answer. -18.9. In the year 2005, what is the difference between the Total Labor Force (in %) in Sub-Saharan Africa (all income levels) and Total Labor Force (in %) in Denmark?
Your answer should be very brief. -6.79. In the year 2005, what is the difference between the Total Labor Force (in %) of Sub-Saharan Africa (all income levels) and Total Labor Force (in %) of Montenegro?
Give a very brief answer. 7.61. In the year 2005, what is the difference between the Total Labor Force (in %) of Sub-Saharan Africa (all income levels) and Total Labor Force (in %) of Paraguay?
Ensure brevity in your answer.  -11.29. In the year 2005, what is the difference between the Total Labor Force (in %) in Montenegro and Total Labor Force (in %) in Paraguay?
Your response must be concise. -18.9. In the year 2006, what is the difference between the Total Labor Force (in %) in Sub-Saharan Africa (all income levels) and Total Labor Force (in %) in Denmark?
Your answer should be very brief. -7.31. In the year 2006, what is the difference between the Total Labor Force (in %) of Sub-Saharan Africa (all income levels) and Total Labor Force (in %) of Montenegro?
Provide a succinct answer. 7.39. In the year 2006, what is the difference between the Total Labor Force (in %) of Sub-Saharan Africa (all income levels) and Total Labor Force (in %) of Paraguay?
Ensure brevity in your answer.  -11.11. In the year 2006, what is the difference between the Total Labor Force (in %) in Montenegro and Total Labor Force (in %) in Paraguay?
Make the answer very short. -18.5. What is the ratio of the Total Labor Force (in %) of Sub-Saharan Africa (all income levels) in 1999 to that in 2000?
Your answer should be very brief. 1. What is the ratio of the Total Labor Force (in %) of Denmark in 1999 to that in 2000?
Your answer should be compact. 1.01. What is the ratio of the Total Labor Force (in %) in Montenegro in 1999 to that in 2000?
Make the answer very short. 1. What is the ratio of the Total Labor Force (in %) in Paraguay in 1999 to that in 2000?
Your answer should be compact. 1.01. What is the ratio of the Total Labor Force (in %) in Sub-Saharan Africa (all income levels) in 1999 to that in 2001?
Your answer should be very brief. 1.01. What is the ratio of the Total Labor Force (in %) of Denmark in 1999 to that in 2001?
Provide a succinct answer. 1.03. What is the ratio of the Total Labor Force (in %) in Paraguay in 1999 to that in 2001?
Offer a very short reply. 1.01. What is the ratio of the Total Labor Force (in %) of Sub-Saharan Africa (all income levels) in 1999 to that in 2002?
Your response must be concise. 1.01. What is the ratio of the Total Labor Force (in %) in Denmark in 1999 to that in 2002?
Keep it short and to the point. 1.02. What is the ratio of the Total Labor Force (in %) of Paraguay in 1999 to that in 2002?
Provide a short and direct response. 1.01. What is the ratio of the Total Labor Force (in %) of Sub-Saharan Africa (all income levels) in 1999 to that in 2003?
Your answer should be very brief. 1.01. What is the ratio of the Total Labor Force (in %) of Denmark in 1999 to that in 2003?
Offer a very short reply. 1.02. What is the ratio of the Total Labor Force (in %) in Paraguay in 1999 to that in 2003?
Provide a succinct answer. 1.01. What is the ratio of the Total Labor Force (in %) of Sub-Saharan Africa (all income levels) in 1999 to that in 2004?
Offer a terse response. 1.02. What is the ratio of the Total Labor Force (in %) in Denmark in 1999 to that in 2004?
Your answer should be very brief. 1.02. What is the ratio of the Total Labor Force (in %) of Montenegro in 1999 to that in 2004?
Keep it short and to the point. 0.99. What is the ratio of the Total Labor Force (in %) in Paraguay in 1999 to that in 2004?
Provide a short and direct response. 1.01. What is the ratio of the Total Labor Force (in %) in Sub-Saharan Africa (all income levels) in 1999 to that in 2005?
Give a very brief answer. 1.02. What is the ratio of the Total Labor Force (in %) of Denmark in 1999 to that in 2005?
Your response must be concise. 1.02. What is the ratio of the Total Labor Force (in %) in Montenegro in 1999 to that in 2005?
Provide a succinct answer. 0.99. What is the ratio of the Total Labor Force (in %) in Paraguay in 1999 to that in 2005?
Keep it short and to the point. 1.01. What is the ratio of the Total Labor Force (in %) of Sub-Saharan Africa (all income levels) in 1999 to that in 2006?
Provide a short and direct response. 1.02. What is the ratio of the Total Labor Force (in %) in Denmark in 1999 to that in 2006?
Give a very brief answer. 1.02. What is the ratio of the Total Labor Force (in %) in Montenegro in 1999 to that in 2006?
Your answer should be very brief. 0.99. What is the ratio of the Total Labor Force (in %) in Paraguay in 1999 to that in 2006?
Make the answer very short. 1.02. What is the ratio of the Total Labor Force (in %) in Denmark in 2000 to that in 2001?
Provide a short and direct response. 1.01. What is the ratio of the Total Labor Force (in %) in Sub-Saharan Africa (all income levels) in 2000 to that in 2002?
Give a very brief answer. 1.01. What is the ratio of the Total Labor Force (in %) in Denmark in 2000 to that in 2002?
Offer a very short reply. 1. What is the ratio of the Total Labor Force (in %) in Montenegro in 2000 to that in 2002?
Keep it short and to the point. 0.99. What is the ratio of the Total Labor Force (in %) in Paraguay in 2000 to that in 2002?
Your answer should be compact. 1.01. What is the ratio of the Total Labor Force (in %) of Sub-Saharan Africa (all income levels) in 2000 to that in 2003?
Keep it short and to the point. 1.01. What is the ratio of the Total Labor Force (in %) of Paraguay in 2000 to that in 2003?
Offer a very short reply. 1.01. What is the ratio of the Total Labor Force (in %) of Sub-Saharan Africa (all income levels) in 2000 to that in 2004?
Your answer should be compact. 1.02. What is the ratio of the Total Labor Force (in %) in Montenegro in 2000 to that in 2004?
Your answer should be very brief. 0.99. What is the ratio of the Total Labor Force (in %) in Paraguay in 2000 to that in 2004?
Offer a very short reply. 1.01. What is the ratio of the Total Labor Force (in %) of Sub-Saharan Africa (all income levels) in 2000 to that in 2005?
Offer a very short reply. 1.02. What is the ratio of the Total Labor Force (in %) in Denmark in 2000 to that in 2005?
Ensure brevity in your answer.  1.01. What is the ratio of the Total Labor Force (in %) in Paraguay in 2000 to that in 2005?
Your response must be concise. 1.01. What is the ratio of the Total Labor Force (in %) of Sub-Saharan Africa (all income levels) in 2000 to that in 2006?
Make the answer very short. 1.01. What is the ratio of the Total Labor Force (in %) of Denmark in 2000 to that in 2006?
Your answer should be very brief. 1. What is the ratio of the Total Labor Force (in %) of Montenegro in 2000 to that in 2006?
Offer a terse response. 0.99. What is the ratio of the Total Labor Force (in %) in Paraguay in 2000 to that in 2006?
Give a very brief answer. 1.01. What is the ratio of the Total Labor Force (in %) in Sub-Saharan Africa (all income levels) in 2001 to that in 2002?
Your response must be concise. 1. What is the ratio of the Total Labor Force (in %) in Denmark in 2001 to that in 2002?
Ensure brevity in your answer.  0.99. What is the ratio of the Total Labor Force (in %) in Montenegro in 2001 to that in 2002?
Your answer should be compact. 1. What is the ratio of the Total Labor Force (in %) in Paraguay in 2001 to that in 2002?
Your answer should be very brief. 1. What is the ratio of the Total Labor Force (in %) of Sub-Saharan Africa (all income levels) in 2001 to that in 2003?
Give a very brief answer. 1.01. What is the ratio of the Total Labor Force (in %) of Montenegro in 2001 to that in 2003?
Your response must be concise. 0.99. What is the ratio of the Total Labor Force (in %) in Sub-Saharan Africa (all income levels) in 2001 to that in 2004?
Provide a short and direct response. 1.01. What is the ratio of the Total Labor Force (in %) of Paraguay in 2001 to that in 2004?
Ensure brevity in your answer.  1. What is the ratio of the Total Labor Force (in %) of Sub-Saharan Africa (all income levels) in 2001 to that in 2005?
Give a very brief answer. 1.01. What is the ratio of the Total Labor Force (in %) in Denmark in 2001 to that in 2005?
Your answer should be compact. 1. What is the ratio of the Total Labor Force (in %) of Montenegro in 2001 to that in 2005?
Provide a succinct answer. 0.99. What is the ratio of the Total Labor Force (in %) in Paraguay in 2001 to that in 2005?
Make the answer very short. 1. What is the ratio of the Total Labor Force (in %) in Sub-Saharan Africa (all income levels) in 2001 to that in 2006?
Offer a very short reply. 1.01. What is the ratio of the Total Labor Force (in %) in Denmark in 2001 to that in 2006?
Your response must be concise. 0.99. What is the ratio of the Total Labor Force (in %) in Paraguay in 2001 to that in 2006?
Make the answer very short. 1. What is the ratio of the Total Labor Force (in %) in Denmark in 2002 to that in 2003?
Keep it short and to the point. 1.01. What is the ratio of the Total Labor Force (in %) of Montenegro in 2002 to that in 2003?
Offer a terse response. 1. What is the ratio of the Total Labor Force (in %) of Paraguay in 2002 to that in 2003?
Keep it short and to the point. 1. What is the ratio of the Total Labor Force (in %) of Denmark in 2002 to that in 2004?
Make the answer very short. 1. What is the ratio of the Total Labor Force (in %) in Montenegro in 2002 to that in 2004?
Your answer should be very brief. 0.99. What is the ratio of the Total Labor Force (in %) of Paraguay in 2002 to that in 2004?
Provide a short and direct response. 1. What is the ratio of the Total Labor Force (in %) in Sub-Saharan Africa (all income levels) in 2002 to that in 2005?
Your answer should be compact. 1.01. What is the ratio of the Total Labor Force (in %) of Paraguay in 2002 to that in 2005?
Your response must be concise. 1. What is the ratio of the Total Labor Force (in %) in Sub-Saharan Africa (all income levels) in 2002 to that in 2006?
Give a very brief answer. 1.01. What is the ratio of the Total Labor Force (in %) of Montenegro in 2002 to that in 2006?
Offer a very short reply. 0.99. What is the ratio of the Total Labor Force (in %) of Paraguay in 2002 to that in 2006?
Your response must be concise. 1. What is the ratio of the Total Labor Force (in %) of Sub-Saharan Africa (all income levels) in 2003 to that in 2004?
Give a very brief answer. 1. What is the ratio of the Total Labor Force (in %) in Denmark in 2003 to that in 2004?
Offer a terse response. 1. What is the ratio of the Total Labor Force (in %) in Paraguay in 2003 to that in 2004?
Provide a succinct answer. 1. What is the ratio of the Total Labor Force (in %) in Sub-Saharan Africa (all income levels) in 2003 to that in 2005?
Your answer should be very brief. 1. What is the ratio of the Total Labor Force (in %) of Paraguay in 2003 to that in 2005?
Offer a terse response. 1. What is the ratio of the Total Labor Force (in %) of Denmark in 2003 to that in 2006?
Your answer should be very brief. 0.99. What is the ratio of the Total Labor Force (in %) in Montenegro in 2003 to that in 2006?
Your answer should be compact. 1. What is the ratio of the Total Labor Force (in %) in Paraguay in 2003 to that in 2006?
Make the answer very short. 1. What is the ratio of the Total Labor Force (in %) in Montenegro in 2004 to that in 2006?
Offer a terse response. 1. What is the ratio of the Total Labor Force (in %) of Montenegro in 2005 to that in 2006?
Your response must be concise. 1. What is the ratio of the Total Labor Force (in %) in Paraguay in 2005 to that in 2006?
Your response must be concise. 1. What is the difference between the highest and the second highest Total Labor Force (in %) of Sub-Saharan Africa (all income levels)?
Provide a succinct answer. 0.23. What is the difference between the highest and the lowest Total Labor Force (in %) of Sub-Saharan Africa (all income levels)?
Keep it short and to the point. 1.5. What is the difference between the highest and the lowest Total Labor Force (in %) in Montenegro?
Your response must be concise. 1. What is the difference between the highest and the lowest Total Labor Force (in %) in Paraguay?
Your answer should be very brief. 1.4. 